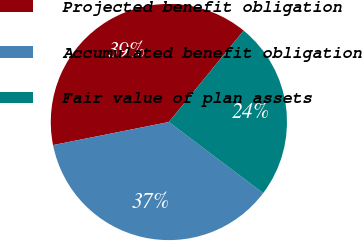Convert chart to OTSL. <chart><loc_0><loc_0><loc_500><loc_500><pie_chart><fcel>Projected benefit obligation<fcel>Accumulated benefit obligation<fcel>Fair value of plan assets<nl><fcel>39.04%<fcel>36.59%<fcel>24.37%<nl></chart> 